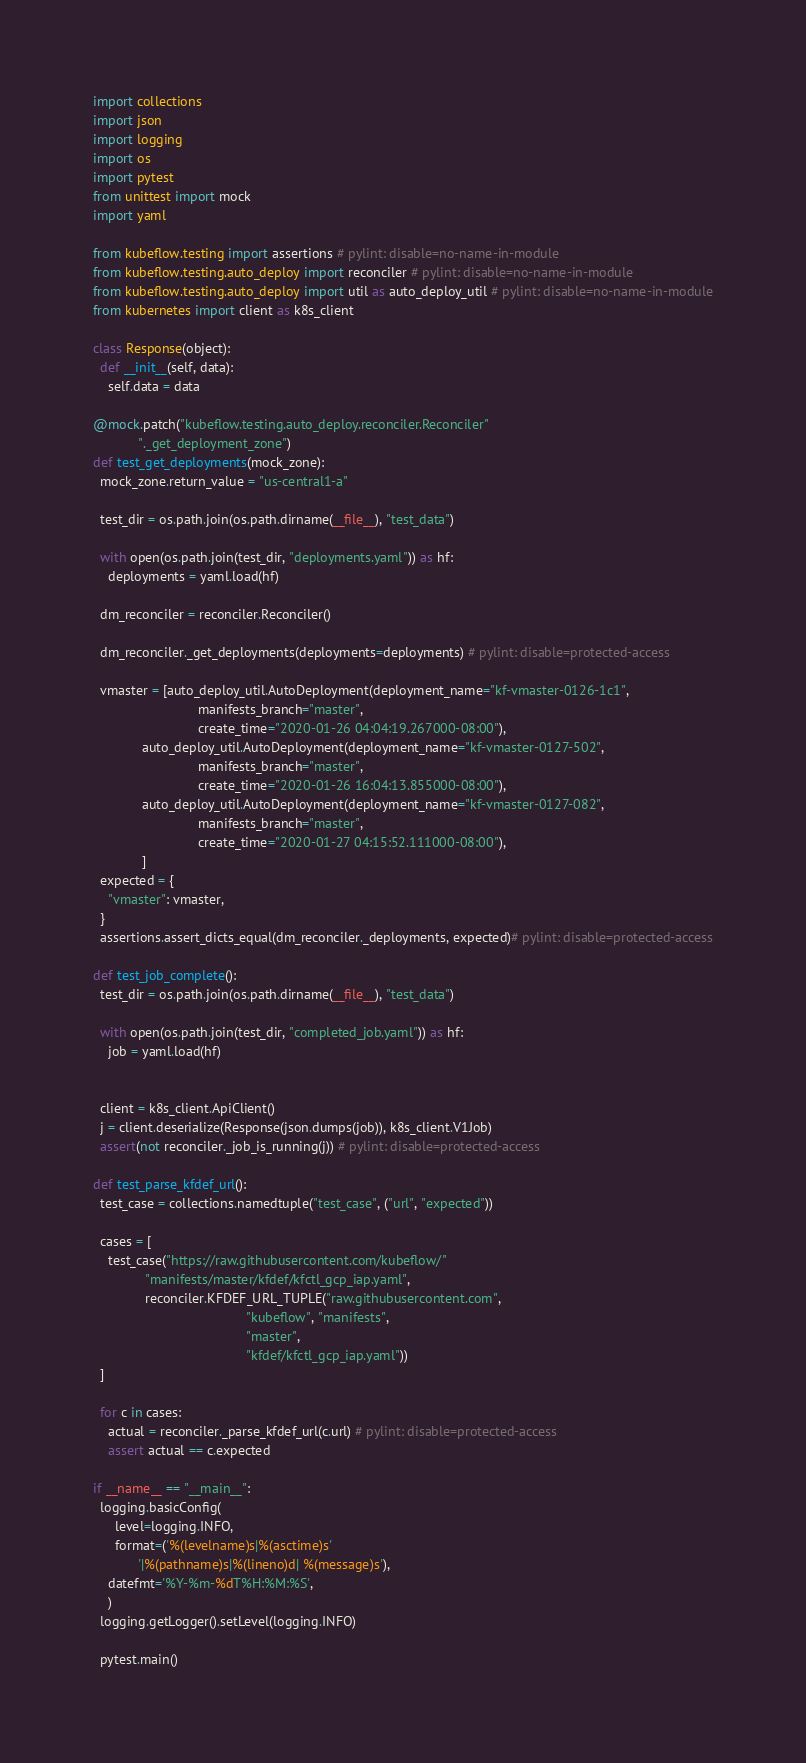Convert code to text. <code><loc_0><loc_0><loc_500><loc_500><_Python_>
import collections
import json
import logging
import os
import pytest
from unittest import mock
import yaml

from kubeflow.testing import assertions # pylint: disable=no-name-in-module
from kubeflow.testing.auto_deploy import reconciler # pylint: disable=no-name-in-module
from kubeflow.testing.auto_deploy import util as auto_deploy_util # pylint: disable=no-name-in-module
from kubernetes import client as k8s_client

class Response(object):
  def __init__(self, data):
    self.data = data

@mock.patch("kubeflow.testing.auto_deploy.reconciler.Reconciler"
            "._get_deployment_zone")
def test_get_deployments(mock_zone):
  mock_zone.return_value = "us-central1-a"

  test_dir = os.path.join(os.path.dirname(__file__), "test_data")

  with open(os.path.join(test_dir, "deployments.yaml")) as hf:
    deployments = yaml.load(hf)

  dm_reconciler = reconciler.Reconciler()

  dm_reconciler._get_deployments(deployments=deployments) # pylint: disable=protected-access

  vmaster = [auto_deploy_util.AutoDeployment(deployment_name="kf-vmaster-0126-1c1",
                            manifests_branch="master",
                            create_time="2020-01-26 04:04:19.267000-08:00"),
             auto_deploy_util.AutoDeployment(deployment_name="kf-vmaster-0127-502",
                            manifests_branch="master",
                            create_time="2020-01-26 16:04:13.855000-08:00"),
             auto_deploy_util.AutoDeployment(deployment_name="kf-vmaster-0127-082",
                            manifests_branch="master",
                            create_time="2020-01-27 04:15:52.111000-08:00"),
             ]
  expected = {
    "vmaster": vmaster,
  }
  assertions.assert_dicts_equal(dm_reconciler._deployments, expected)# pylint: disable=protected-access

def test_job_complete():
  test_dir = os.path.join(os.path.dirname(__file__), "test_data")

  with open(os.path.join(test_dir, "completed_job.yaml")) as hf:
    job = yaml.load(hf)


  client = k8s_client.ApiClient()
  j = client.deserialize(Response(json.dumps(job)), k8s_client.V1Job)
  assert(not reconciler._job_is_running(j)) # pylint: disable=protected-access

def test_parse_kfdef_url():
  test_case = collections.namedtuple("test_case", ("url", "expected"))

  cases = [
    test_case("https://raw.githubusercontent.com/kubeflow/"
              "manifests/master/kfdef/kfctl_gcp_iap.yaml",
              reconciler.KFDEF_URL_TUPLE("raw.githubusercontent.com",
                                         "kubeflow", "manifests",
                                         "master",
                                         "kfdef/kfctl_gcp_iap.yaml"))
  ]

  for c in cases:
    actual = reconciler._parse_kfdef_url(c.url) # pylint: disable=protected-access
    assert actual == c.expected

if __name__ == "__main__":
  logging.basicConfig(
      level=logging.INFO,
      format=('%(levelname)s|%(asctime)s'
            '|%(pathname)s|%(lineno)d| %(message)s'),
    datefmt='%Y-%m-%dT%H:%M:%S',
    )
  logging.getLogger().setLevel(logging.INFO)

  pytest.main()
</code> 